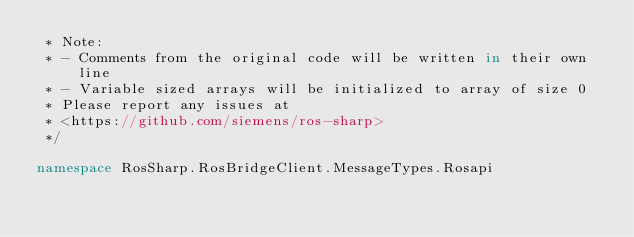Convert code to text. <code><loc_0><loc_0><loc_500><loc_500><_C#_> * Note:
 * - Comments from the original code will be written in their own line 
 * - Variable sized arrays will be initialized to array of size 0 
 * Please report any issues at 
 * <https://github.com/siemens/ros-sharp> 
 */

namespace RosSharp.RosBridgeClient.MessageTypes.Rosapi</code> 